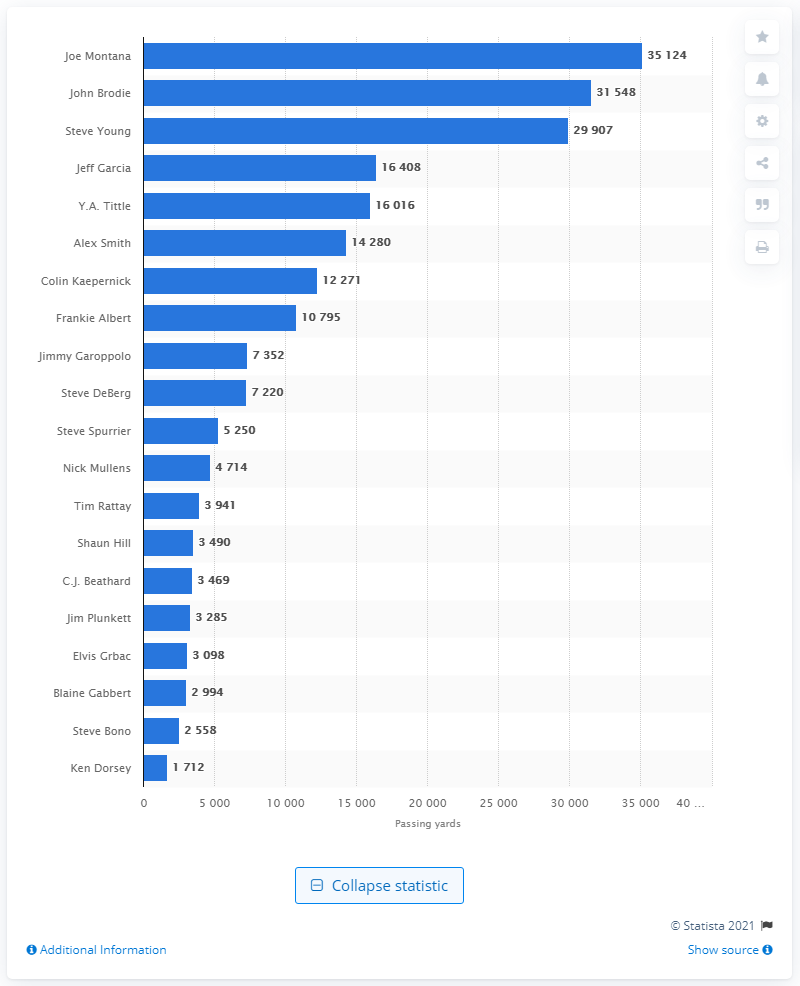Highlight a few significant elements in this photo. Joe Montana is the career passing leader of the San Francisco 49ers. 